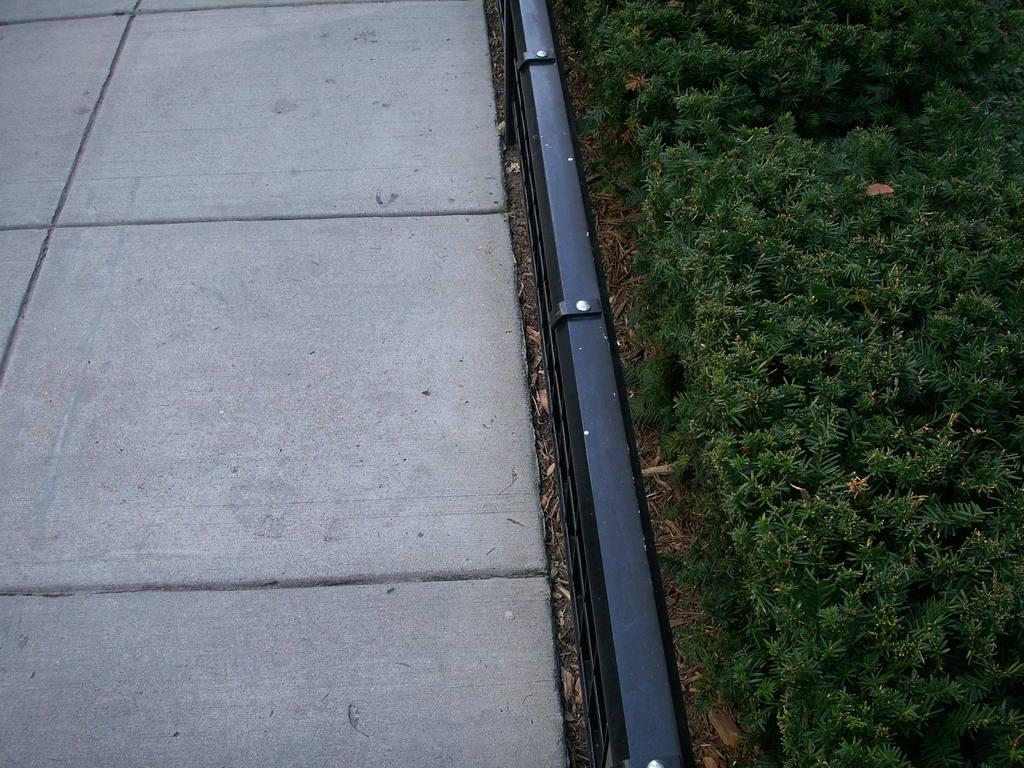What type of vegetation is on the right side of the image? There is grass on the right side of the image. What can be seen in the middle of the image? There is a railing in the middle of the image. What is the surface on the left side of the image? There is a floor on the left side of the image. What type of linen is draped over the railing in the image? There is no linen present in the image; the railing is the only object mentioned in the middle of the image. What type of wool is visible on the grass in the image? There is no wool present in the image; only grass is mentioned on the right side of the image. 